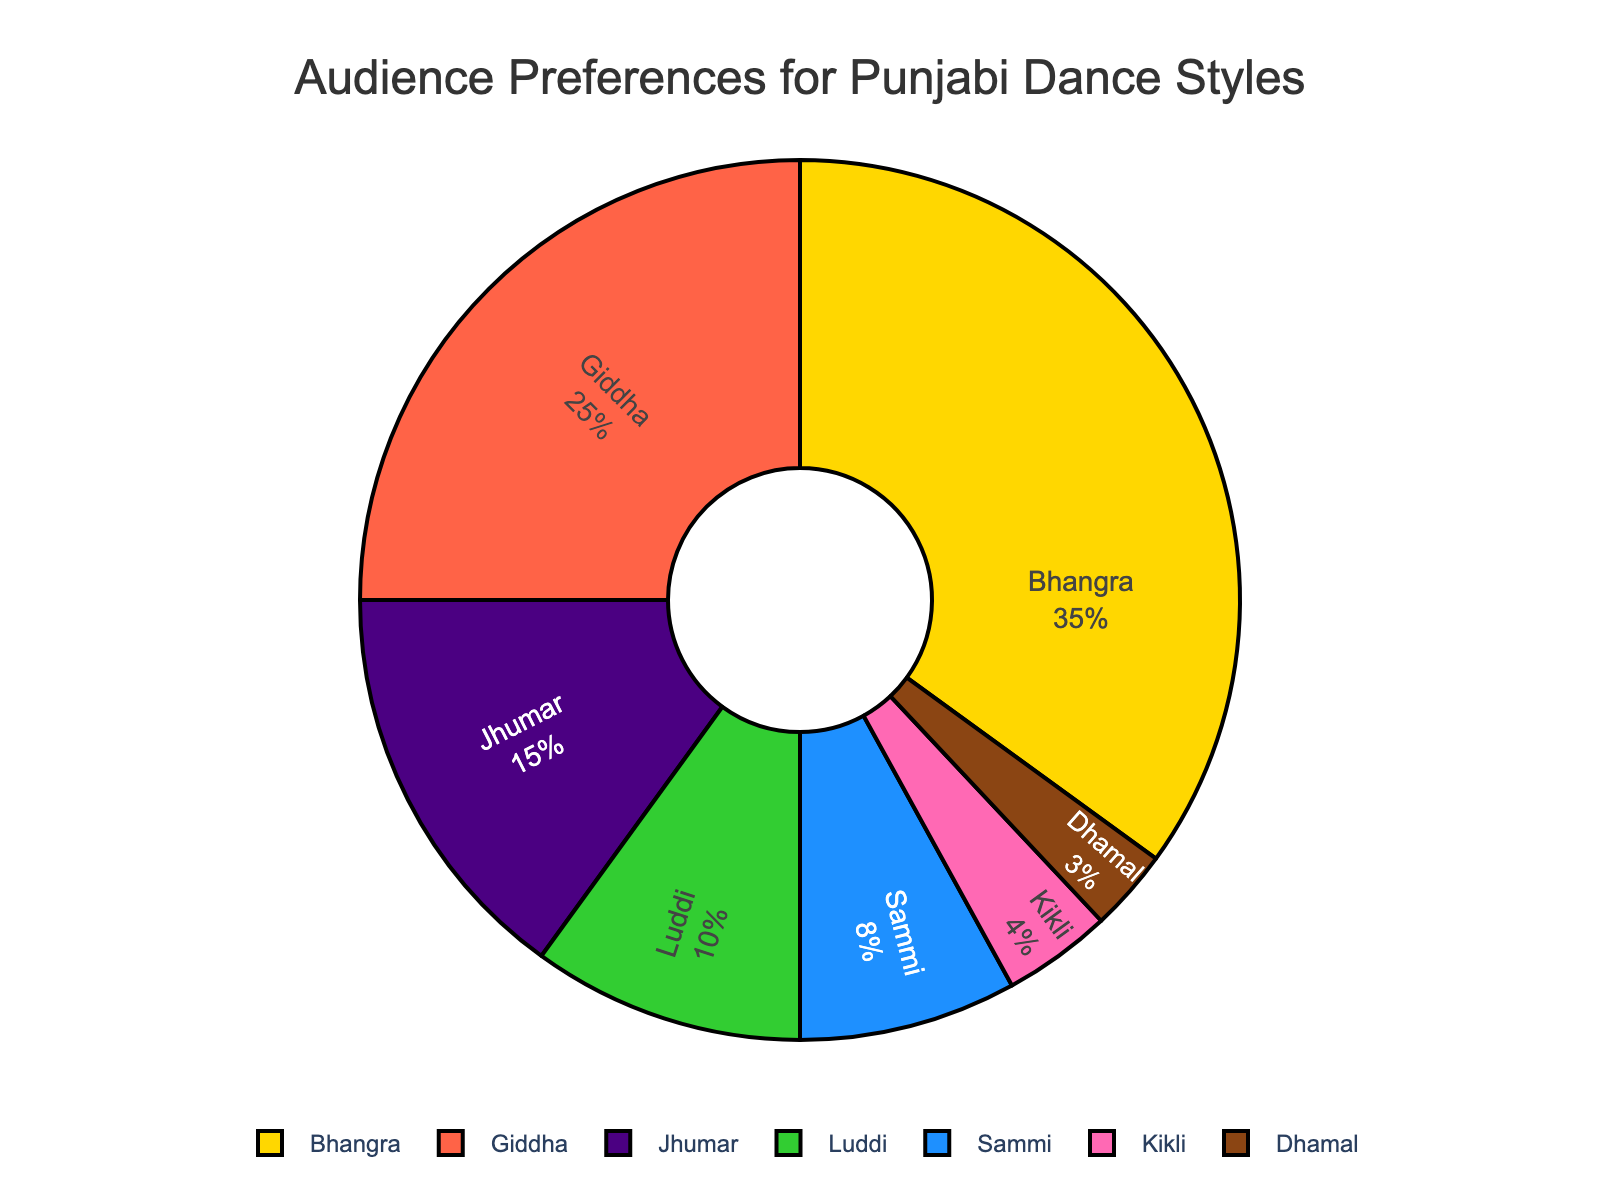What dance style commands the highest audience preference? The figure shows the percentage of audience preferences for various dance styles, and Bhangra has the largest slice of the pie chart.
Answer: Bhangra Which dance styles together make up more than 50% of the audience preferences? Adding the percentages from the largest segments, Bhangra (35%) and Giddha (25%) together make up 60%, which surpasses 50%.
Answer: Bhangra and Giddha What is the combined percentage for Giddha and Jhumar? From the pie chart, Giddha is 25% and Jhumar is 15%. Adding these, 25% + 15% = 40%.
Answer: 40% Which dance style is preferred by a smaller audience segment than Luddi but larger than Kikli? The pie chart shows Luddi at 10% and Kikli at 4%. Between these percentages, Sammi fits at 8%.
Answer: Sammi How much more popular is Bhangra compared to Luddi? The percentage for Bhangra is 35% and for Luddi is 10%. The difference is 35% - 10% = 25%.
Answer: 25% Which dance styles have a single-digit percentage preference? Styles that have less than 10% in the pie chart are Sammi (8%), Kikli (4%), and Dhamal (3%).
Answer: Sammi, Kikli, Dhamal If we were to organize an event featuring only the four least popular dance styles, what percentage of the audience's preference are we targeting? Adding the percentages of Jhumar (15%), Luddi (10%), Sammi (8%), Kikli (4%), and Dhamal (3%), gives 15% + 10% + 8% + 4% + 3% = 40%.
Answer: 40% By how much does the sum of the percentages of Bhangra and Giddha exceed the total percentage of Luddi, Sammi, Kikli, and Dhamal? Bhangra and Giddha together have 35% + 25% = 60%. Luddi, Sammi, Kikli, and Dhamal together have 10% + 8% + 4% + 3% = 25%. The difference is 60% - 25% = 35%.
Answer: 35% 